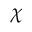Convert formula to latex. <formula><loc_0><loc_0><loc_500><loc_500>\chi</formula> 